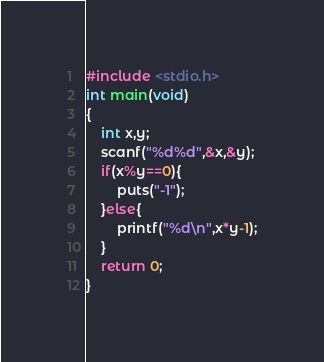<code> <loc_0><loc_0><loc_500><loc_500><_C++_>#include <stdio.h>
int main(void)
{
	int x,y;
	scanf("%d%d",&x,&y);
	if(x%y==0){
		puts("-1");
	}else{
		printf("%d\n",x*y-1);
	}
	return 0;
}</code> 